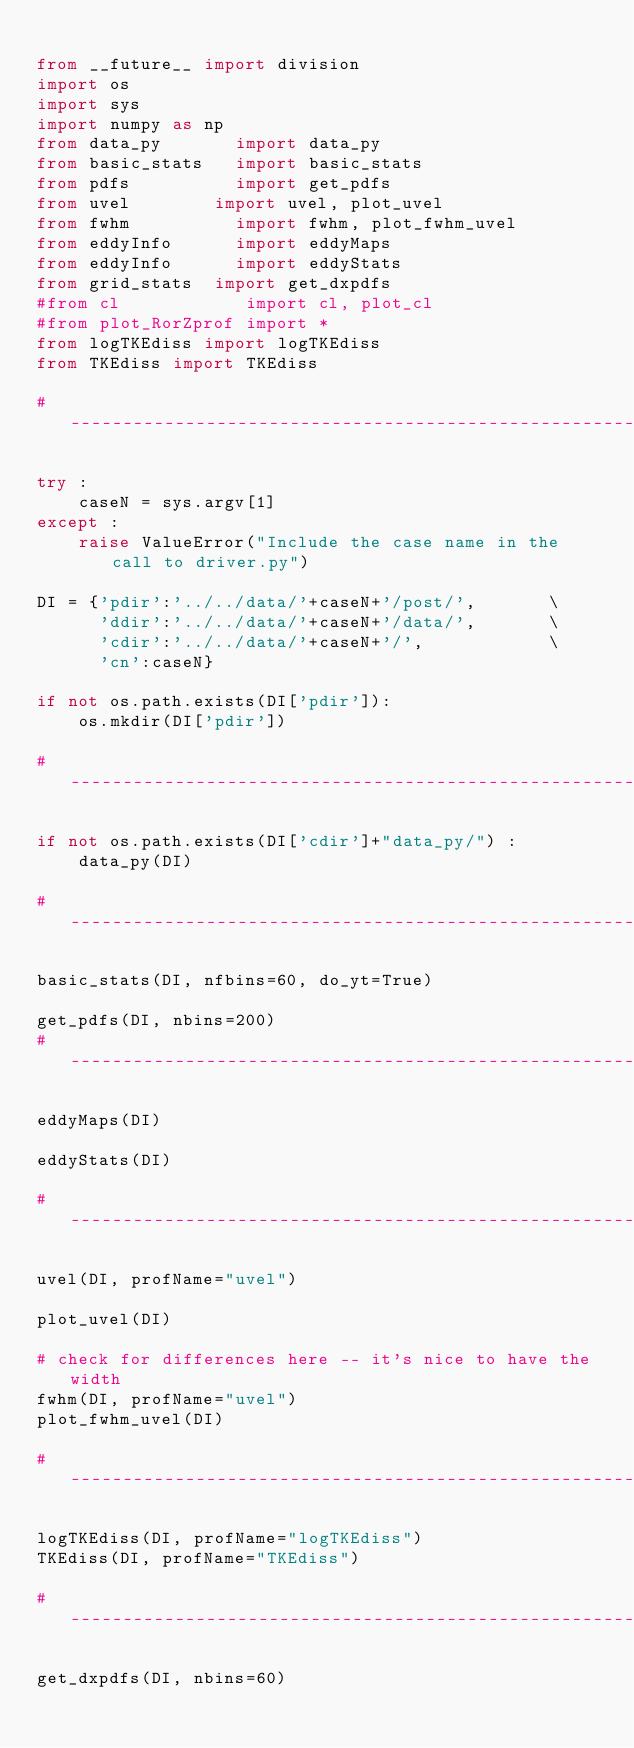<code> <loc_0><loc_0><loc_500><loc_500><_Python_>
from __future__ import division
import os
import sys
import numpy as np
from data_py       import data_py
from basic_stats   import basic_stats
from pdfs          import get_pdfs
from uvel        import uvel, plot_uvel
from fwhm          import fwhm, plot_fwhm_uvel
from eddyInfo      import eddyMaps
from eddyInfo      import eddyStats
from grid_stats  import get_dxpdfs
#from cl            import cl, plot_cl
#from plot_RorZprof import *
from logTKEdiss import logTKEdiss
from TKEdiss import TKEdiss

#--------------------------------------------------------------------------------------------

try :
    caseN = sys.argv[1]
except :
    raise ValueError("Include the case name in the call to driver.py")

DI = {'pdir':'../../data/'+caseN+'/post/',       \
      'ddir':'../../data/'+caseN+'/data/',       \
      'cdir':'../../data/'+caseN+'/',            \
      'cn':caseN}

if not os.path.exists(DI['pdir']):
    os.mkdir(DI['pdir'])

#--------------------------------------------------------------------------------------------

if not os.path.exists(DI['cdir']+"data_py/") :
    data_py(DI)

#--------------------------------------------------------------------------------------------

basic_stats(DI, nfbins=60, do_yt=True)

get_pdfs(DI, nbins=200)
#--------------------------------------------------------------------------------------------

eddyMaps(DI)

eddyStats(DI)

#--------------------------------------------------------------------------------------------

uvel(DI, profName="uvel")

plot_uvel(DI)

# check for differences here -- it's nice to have the width
fwhm(DI, profName="uvel")
plot_fwhm_uvel(DI)

#--------------------------------------------------------------------------------------------

logTKEdiss(DI, profName="logTKEdiss")
TKEdiss(DI, profName="TKEdiss")

#--------------------------------------------------------------------------------------------

get_dxpdfs(DI, nbins=60)

</code> 